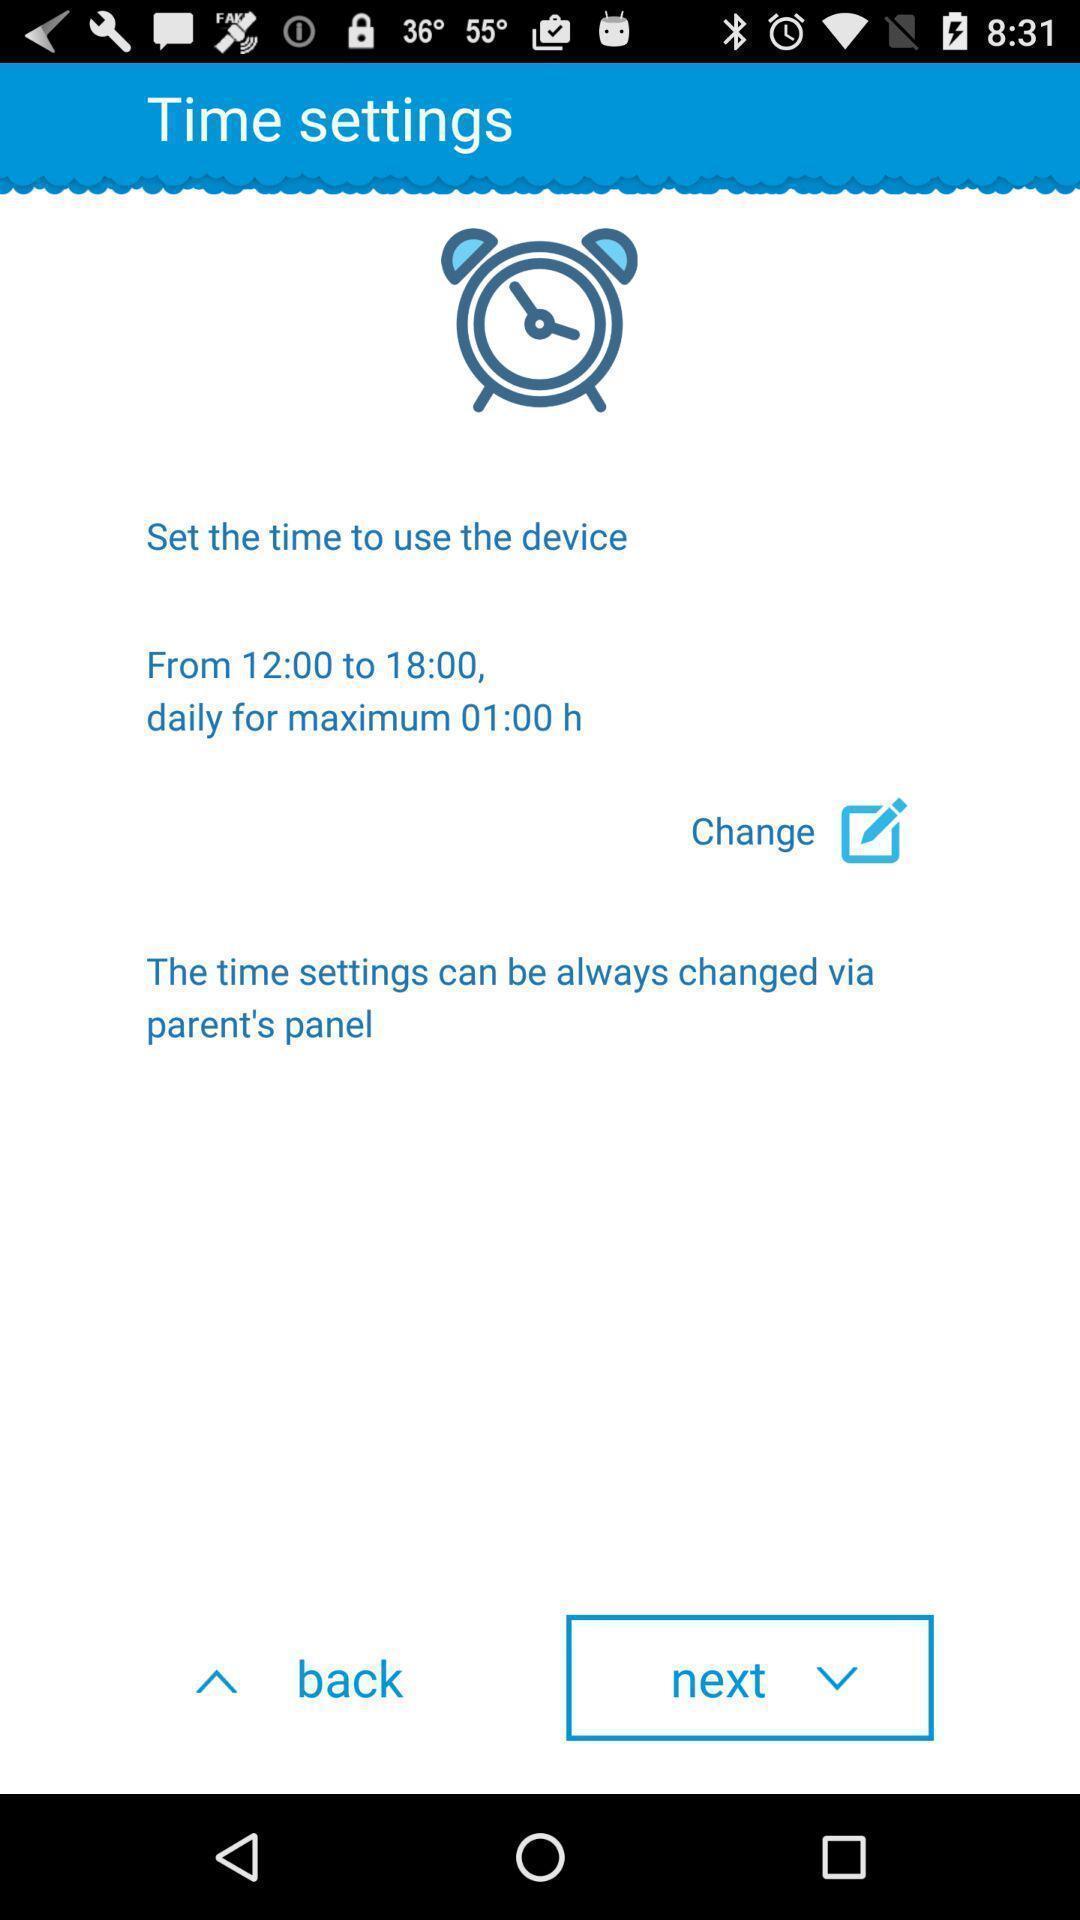What can you discern from this picture? Settings page of an alarm application. 